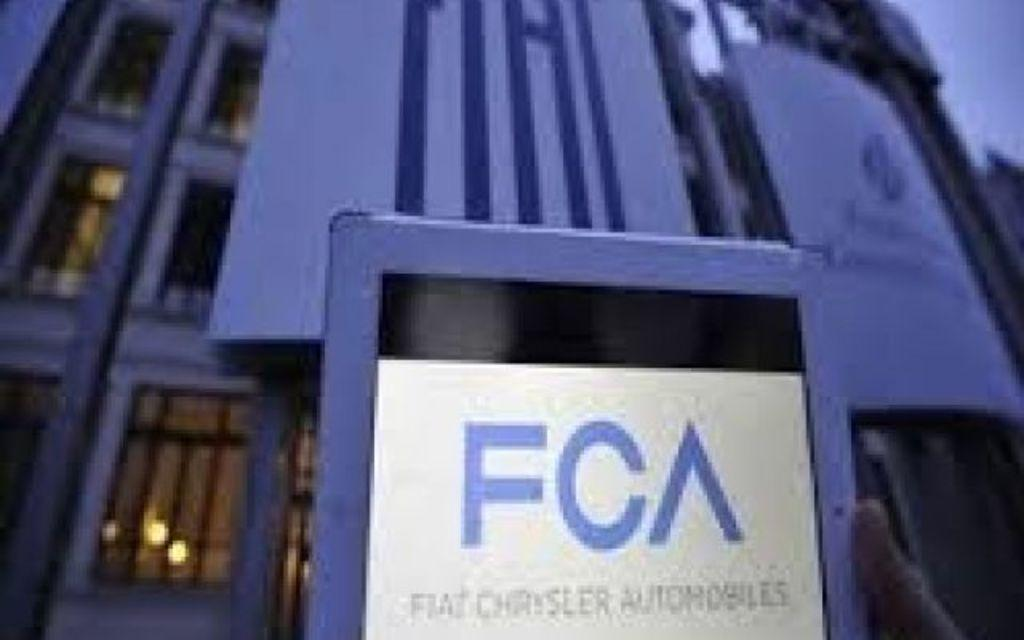What is the main object in the image? There is a blue color board in the image. What is attached to the color board? A paper is attached to the board. What can be found on the paper? There is text on the paper. What can be seen in the background of the image? There is a building in the background of the image. How many birds are sitting on the color board in the image? There are no birds present in the image; it only features a blue color board with a paper attached. 